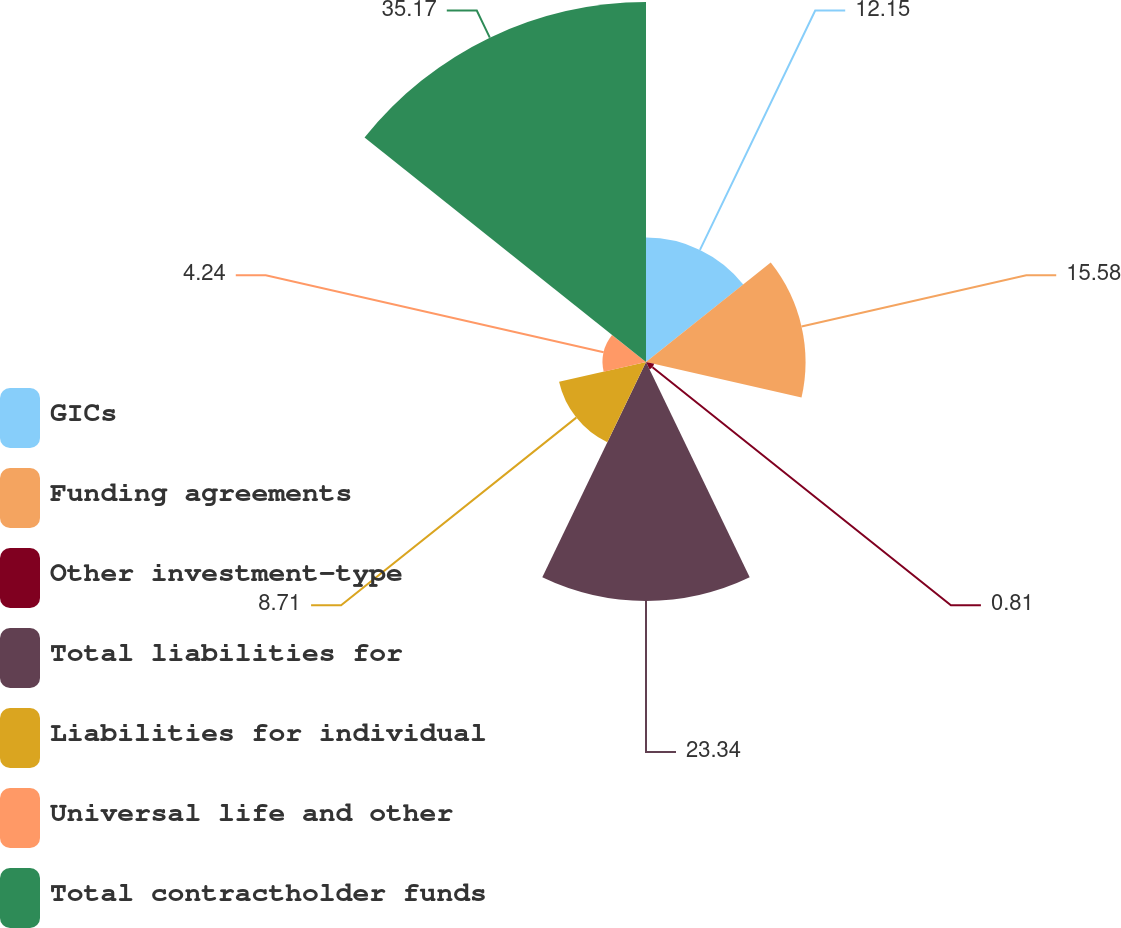Convert chart to OTSL. <chart><loc_0><loc_0><loc_500><loc_500><pie_chart><fcel>GICs<fcel>Funding agreements<fcel>Other investment-type<fcel>Total liabilities for<fcel>Liabilities for individual<fcel>Universal life and other<fcel>Total contractholder funds<nl><fcel>12.15%<fcel>15.58%<fcel>0.81%<fcel>23.34%<fcel>8.71%<fcel>4.24%<fcel>35.16%<nl></chart> 